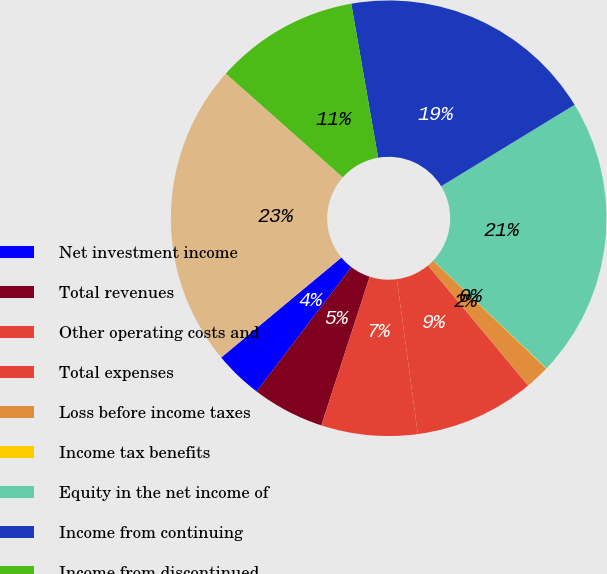<chart> <loc_0><loc_0><loc_500><loc_500><pie_chart><fcel>Net investment income<fcel>Total revenues<fcel>Other operating costs and<fcel>Total expenses<fcel>Loss before income taxes<fcel>Income tax benefits<fcel>Equity in the net income of<fcel>Income from continuing<fcel>Income from discontinued<fcel>Net income<nl><fcel>3.59%<fcel>5.37%<fcel>7.14%<fcel>8.92%<fcel>1.81%<fcel>0.04%<fcel>20.81%<fcel>19.03%<fcel>10.7%<fcel>22.59%<nl></chart> 